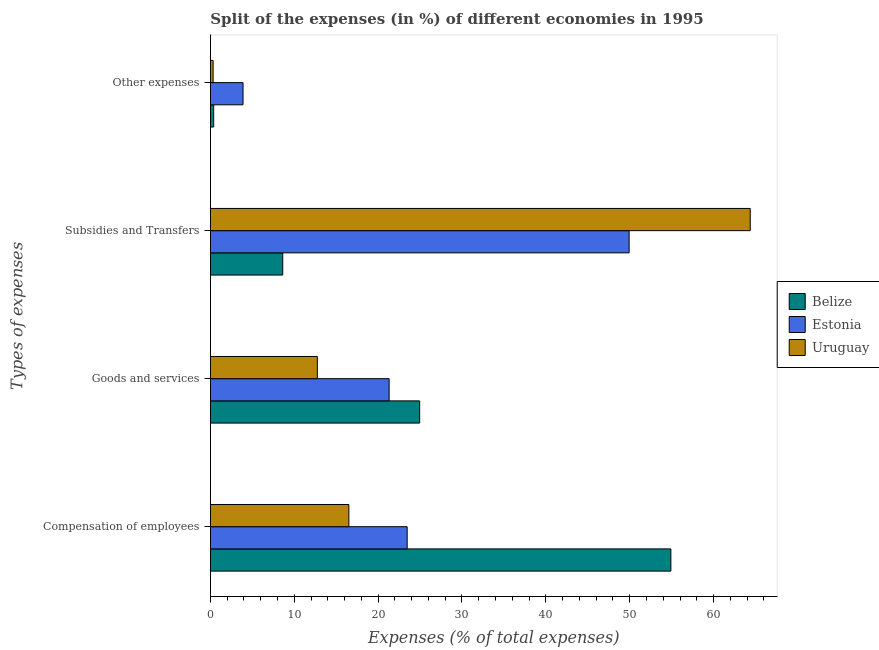How many groups of bars are there?
Your response must be concise. 4. Are the number of bars per tick equal to the number of legend labels?
Offer a very short reply. Yes. How many bars are there on the 4th tick from the top?
Ensure brevity in your answer.  3. How many bars are there on the 3rd tick from the bottom?
Provide a succinct answer. 3. What is the label of the 3rd group of bars from the top?
Give a very brief answer. Goods and services. What is the percentage of amount spent on subsidies in Belize?
Keep it short and to the point. 8.63. Across all countries, what is the maximum percentage of amount spent on goods and services?
Make the answer very short. 24.95. Across all countries, what is the minimum percentage of amount spent on goods and services?
Provide a succinct answer. 12.75. In which country was the percentage of amount spent on goods and services maximum?
Provide a short and direct response. Belize. In which country was the percentage of amount spent on goods and services minimum?
Offer a very short reply. Uruguay. What is the total percentage of amount spent on other expenses in the graph?
Your response must be concise. 4.61. What is the difference between the percentage of amount spent on goods and services in Estonia and that in Uruguay?
Provide a succinct answer. 8.56. What is the difference between the percentage of amount spent on compensation of employees in Estonia and the percentage of amount spent on subsidies in Uruguay?
Ensure brevity in your answer.  -40.9. What is the average percentage of amount spent on subsidies per country?
Your answer should be very brief. 40.97. What is the difference between the percentage of amount spent on other expenses and percentage of amount spent on subsidies in Estonia?
Offer a terse response. -46.04. In how many countries, is the percentage of amount spent on goods and services greater than 60 %?
Your answer should be compact. 0. What is the ratio of the percentage of amount spent on goods and services in Uruguay to that in Belize?
Ensure brevity in your answer.  0.51. Is the percentage of amount spent on goods and services in Belize less than that in Estonia?
Keep it short and to the point. No. Is the difference between the percentage of amount spent on other expenses in Uruguay and Belize greater than the difference between the percentage of amount spent on subsidies in Uruguay and Belize?
Your answer should be very brief. No. What is the difference between the highest and the second highest percentage of amount spent on compensation of employees?
Provide a succinct answer. 31.44. What is the difference between the highest and the lowest percentage of amount spent on other expenses?
Provide a succinct answer. 3.57. In how many countries, is the percentage of amount spent on other expenses greater than the average percentage of amount spent on other expenses taken over all countries?
Provide a succinct answer. 1. Is the sum of the percentage of amount spent on goods and services in Estonia and Belize greater than the maximum percentage of amount spent on other expenses across all countries?
Keep it short and to the point. Yes. What does the 1st bar from the top in Compensation of employees represents?
Make the answer very short. Uruguay. What does the 1st bar from the bottom in Compensation of employees represents?
Ensure brevity in your answer.  Belize. Is it the case that in every country, the sum of the percentage of amount spent on compensation of employees and percentage of amount spent on goods and services is greater than the percentage of amount spent on subsidies?
Make the answer very short. No. Are all the bars in the graph horizontal?
Ensure brevity in your answer.  Yes. How many countries are there in the graph?
Offer a very short reply. 3. Are the values on the major ticks of X-axis written in scientific E-notation?
Make the answer very short. No. Where does the legend appear in the graph?
Your answer should be very brief. Center right. How are the legend labels stacked?
Make the answer very short. Vertical. What is the title of the graph?
Make the answer very short. Split of the expenses (in %) of different economies in 1995. Does "Luxembourg" appear as one of the legend labels in the graph?
Make the answer very short. No. What is the label or title of the X-axis?
Give a very brief answer. Expenses (% of total expenses). What is the label or title of the Y-axis?
Give a very brief answer. Types of expenses. What is the Expenses (% of total expenses) of Belize in Compensation of employees?
Provide a succinct answer. 54.91. What is the Expenses (% of total expenses) in Estonia in Compensation of employees?
Make the answer very short. 23.46. What is the Expenses (% of total expenses) of Uruguay in Compensation of employees?
Make the answer very short. 16.51. What is the Expenses (% of total expenses) of Belize in Goods and services?
Keep it short and to the point. 24.95. What is the Expenses (% of total expenses) in Estonia in Goods and services?
Make the answer very short. 21.31. What is the Expenses (% of total expenses) of Uruguay in Goods and services?
Ensure brevity in your answer.  12.75. What is the Expenses (% of total expenses) in Belize in Subsidies and Transfers?
Ensure brevity in your answer.  8.63. What is the Expenses (% of total expenses) of Estonia in Subsidies and Transfers?
Offer a very short reply. 49.93. What is the Expenses (% of total expenses) in Uruguay in Subsidies and Transfers?
Your answer should be very brief. 64.37. What is the Expenses (% of total expenses) in Belize in Other expenses?
Keep it short and to the point. 0.39. What is the Expenses (% of total expenses) in Estonia in Other expenses?
Make the answer very short. 3.89. What is the Expenses (% of total expenses) of Uruguay in Other expenses?
Your response must be concise. 0.33. Across all Types of expenses, what is the maximum Expenses (% of total expenses) in Belize?
Keep it short and to the point. 54.91. Across all Types of expenses, what is the maximum Expenses (% of total expenses) of Estonia?
Provide a short and direct response. 49.93. Across all Types of expenses, what is the maximum Expenses (% of total expenses) in Uruguay?
Your answer should be very brief. 64.37. Across all Types of expenses, what is the minimum Expenses (% of total expenses) in Belize?
Your answer should be very brief. 0.39. Across all Types of expenses, what is the minimum Expenses (% of total expenses) of Estonia?
Provide a succinct answer. 3.89. Across all Types of expenses, what is the minimum Expenses (% of total expenses) in Uruguay?
Give a very brief answer. 0.33. What is the total Expenses (% of total expenses) of Belize in the graph?
Offer a terse response. 88.88. What is the total Expenses (% of total expenses) of Estonia in the graph?
Your answer should be compact. 98.6. What is the total Expenses (% of total expenses) of Uruguay in the graph?
Provide a short and direct response. 93.96. What is the difference between the Expenses (% of total expenses) in Belize in Compensation of employees and that in Goods and services?
Provide a short and direct response. 29.95. What is the difference between the Expenses (% of total expenses) in Estonia in Compensation of employees and that in Goods and services?
Your answer should be very brief. 2.15. What is the difference between the Expenses (% of total expenses) in Uruguay in Compensation of employees and that in Goods and services?
Give a very brief answer. 3.76. What is the difference between the Expenses (% of total expenses) in Belize in Compensation of employees and that in Subsidies and Transfers?
Keep it short and to the point. 46.28. What is the difference between the Expenses (% of total expenses) of Estonia in Compensation of employees and that in Subsidies and Transfers?
Offer a very short reply. -26.46. What is the difference between the Expenses (% of total expenses) of Uruguay in Compensation of employees and that in Subsidies and Transfers?
Offer a terse response. -47.86. What is the difference between the Expenses (% of total expenses) in Belize in Compensation of employees and that in Other expenses?
Your answer should be compact. 54.51. What is the difference between the Expenses (% of total expenses) in Estonia in Compensation of employees and that in Other expenses?
Provide a succinct answer. 19.57. What is the difference between the Expenses (% of total expenses) of Uruguay in Compensation of employees and that in Other expenses?
Your answer should be very brief. 16.19. What is the difference between the Expenses (% of total expenses) of Belize in Goods and services and that in Subsidies and Transfers?
Provide a succinct answer. 16.33. What is the difference between the Expenses (% of total expenses) in Estonia in Goods and services and that in Subsidies and Transfers?
Offer a very short reply. -28.61. What is the difference between the Expenses (% of total expenses) in Uruguay in Goods and services and that in Subsidies and Transfers?
Your answer should be compact. -51.61. What is the difference between the Expenses (% of total expenses) in Belize in Goods and services and that in Other expenses?
Keep it short and to the point. 24.56. What is the difference between the Expenses (% of total expenses) in Estonia in Goods and services and that in Other expenses?
Provide a succinct answer. 17.42. What is the difference between the Expenses (% of total expenses) in Uruguay in Goods and services and that in Other expenses?
Provide a succinct answer. 12.43. What is the difference between the Expenses (% of total expenses) in Belize in Subsidies and Transfers and that in Other expenses?
Your answer should be very brief. 8.23. What is the difference between the Expenses (% of total expenses) in Estonia in Subsidies and Transfers and that in Other expenses?
Offer a terse response. 46.04. What is the difference between the Expenses (% of total expenses) in Uruguay in Subsidies and Transfers and that in Other expenses?
Your answer should be very brief. 64.04. What is the difference between the Expenses (% of total expenses) of Belize in Compensation of employees and the Expenses (% of total expenses) of Estonia in Goods and services?
Keep it short and to the point. 33.59. What is the difference between the Expenses (% of total expenses) in Belize in Compensation of employees and the Expenses (% of total expenses) in Uruguay in Goods and services?
Your answer should be compact. 42.15. What is the difference between the Expenses (% of total expenses) of Estonia in Compensation of employees and the Expenses (% of total expenses) of Uruguay in Goods and services?
Give a very brief answer. 10.71. What is the difference between the Expenses (% of total expenses) of Belize in Compensation of employees and the Expenses (% of total expenses) of Estonia in Subsidies and Transfers?
Your answer should be compact. 4.98. What is the difference between the Expenses (% of total expenses) in Belize in Compensation of employees and the Expenses (% of total expenses) in Uruguay in Subsidies and Transfers?
Give a very brief answer. -9.46. What is the difference between the Expenses (% of total expenses) of Estonia in Compensation of employees and the Expenses (% of total expenses) of Uruguay in Subsidies and Transfers?
Your answer should be compact. -40.9. What is the difference between the Expenses (% of total expenses) in Belize in Compensation of employees and the Expenses (% of total expenses) in Estonia in Other expenses?
Your response must be concise. 51.01. What is the difference between the Expenses (% of total expenses) of Belize in Compensation of employees and the Expenses (% of total expenses) of Uruguay in Other expenses?
Offer a terse response. 54.58. What is the difference between the Expenses (% of total expenses) in Estonia in Compensation of employees and the Expenses (% of total expenses) in Uruguay in Other expenses?
Offer a terse response. 23.14. What is the difference between the Expenses (% of total expenses) in Belize in Goods and services and the Expenses (% of total expenses) in Estonia in Subsidies and Transfers?
Offer a terse response. -24.97. What is the difference between the Expenses (% of total expenses) of Belize in Goods and services and the Expenses (% of total expenses) of Uruguay in Subsidies and Transfers?
Give a very brief answer. -39.41. What is the difference between the Expenses (% of total expenses) of Estonia in Goods and services and the Expenses (% of total expenses) of Uruguay in Subsidies and Transfers?
Your answer should be compact. -43.05. What is the difference between the Expenses (% of total expenses) in Belize in Goods and services and the Expenses (% of total expenses) in Estonia in Other expenses?
Your answer should be compact. 21.06. What is the difference between the Expenses (% of total expenses) of Belize in Goods and services and the Expenses (% of total expenses) of Uruguay in Other expenses?
Give a very brief answer. 24.63. What is the difference between the Expenses (% of total expenses) in Estonia in Goods and services and the Expenses (% of total expenses) in Uruguay in Other expenses?
Your response must be concise. 20.99. What is the difference between the Expenses (% of total expenses) in Belize in Subsidies and Transfers and the Expenses (% of total expenses) in Estonia in Other expenses?
Your answer should be very brief. 4.73. What is the difference between the Expenses (% of total expenses) in Belize in Subsidies and Transfers and the Expenses (% of total expenses) in Uruguay in Other expenses?
Ensure brevity in your answer.  8.3. What is the difference between the Expenses (% of total expenses) in Estonia in Subsidies and Transfers and the Expenses (% of total expenses) in Uruguay in Other expenses?
Offer a very short reply. 49.6. What is the average Expenses (% of total expenses) in Belize per Types of expenses?
Offer a terse response. 22.22. What is the average Expenses (% of total expenses) of Estonia per Types of expenses?
Your response must be concise. 24.65. What is the average Expenses (% of total expenses) of Uruguay per Types of expenses?
Provide a short and direct response. 23.49. What is the difference between the Expenses (% of total expenses) in Belize and Expenses (% of total expenses) in Estonia in Compensation of employees?
Your response must be concise. 31.44. What is the difference between the Expenses (% of total expenses) of Belize and Expenses (% of total expenses) of Uruguay in Compensation of employees?
Offer a very short reply. 38.4. What is the difference between the Expenses (% of total expenses) of Estonia and Expenses (% of total expenses) of Uruguay in Compensation of employees?
Offer a terse response. 6.95. What is the difference between the Expenses (% of total expenses) in Belize and Expenses (% of total expenses) in Estonia in Goods and services?
Ensure brevity in your answer.  3.64. What is the difference between the Expenses (% of total expenses) of Belize and Expenses (% of total expenses) of Uruguay in Goods and services?
Offer a very short reply. 12.2. What is the difference between the Expenses (% of total expenses) of Estonia and Expenses (% of total expenses) of Uruguay in Goods and services?
Give a very brief answer. 8.56. What is the difference between the Expenses (% of total expenses) of Belize and Expenses (% of total expenses) of Estonia in Subsidies and Transfers?
Keep it short and to the point. -41.3. What is the difference between the Expenses (% of total expenses) of Belize and Expenses (% of total expenses) of Uruguay in Subsidies and Transfers?
Your answer should be compact. -55.74. What is the difference between the Expenses (% of total expenses) of Estonia and Expenses (% of total expenses) of Uruguay in Subsidies and Transfers?
Your answer should be compact. -14.44. What is the difference between the Expenses (% of total expenses) of Belize and Expenses (% of total expenses) of Estonia in Other expenses?
Your answer should be very brief. -3.5. What is the difference between the Expenses (% of total expenses) of Belize and Expenses (% of total expenses) of Uruguay in Other expenses?
Your response must be concise. 0.07. What is the difference between the Expenses (% of total expenses) in Estonia and Expenses (% of total expenses) in Uruguay in Other expenses?
Give a very brief answer. 3.57. What is the ratio of the Expenses (% of total expenses) in Belize in Compensation of employees to that in Goods and services?
Keep it short and to the point. 2.2. What is the ratio of the Expenses (% of total expenses) in Estonia in Compensation of employees to that in Goods and services?
Your answer should be very brief. 1.1. What is the ratio of the Expenses (% of total expenses) in Uruguay in Compensation of employees to that in Goods and services?
Keep it short and to the point. 1.29. What is the ratio of the Expenses (% of total expenses) in Belize in Compensation of employees to that in Subsidies and Transfers?
Provide a succinct answer. 6.37. What is the ratio of the Expenses (% of total expenses) in Estonia in Compensation of employees to that in Subsidies and Transfers?
Give a very brief answer. 0.47. What is the ratio of the Expenses (% of total expenses) in Uruguay in Compensation of employees to that in Subsidies and Transfers?
Ensure brevity in your answer.  0.26. What is the ratio of the Expenses (% of total expenses) in Belize in Compensation of employees to that in Other expenses?
Your response must be concise. 139.55. What is the ratio of the Expenses (% of total expenses) of Estonia in Compensation of employees to that in Other expenses?
Provide a short and direct response. 6.03. What is the ratio of the Expenses (% of total expenses) in Uruguay in Compensation of employees to that in Other expenses?
Provide a short and direct response. 50.77. What is the ratio of the Expenses (% of total expenses) in Belize in Goods and services to that in Subsidies and Transfers?
Keep it short and to the point. 2.89. What is the ratio of the Expenses (% of total expenses) in Estonia in Goods and services to that in Subsidies and Transfers?
Offer a very short reply. 0.43. What is the ratio of the Expenses (% of total expenses) in Uruguay in Goods and services to that in Subsidies and Transfers?
Your response must be concise. 0.2. What is the ratio of the Expenses (% of total expenses) in Belize in Goods and services to that in Other expenses?
Keep it short and to the point. 63.42. What is the ratio of the Expenses (% of total expenses) of Estonia in Goods and services to that in Other expenses?
Keep it short and to the point. 5.48. What is the ratio of the Expenses (% of total expenses) in Uruguay in Goods and services to that in Other expenses?
Your answer should be compact. 39.21. What is the ratio of the Expenses (% of total expenses) in Belize in Subsidies and Transfers to that in Other expenses?
Make the answer very short. 21.92. What is the ratio of the Expenses (% of total expenses) in Estonia in Subsidies and Transfers to that in Other expenses?
Give a very brief answer. 12.83. What is the ratio of the Expenses (% of total expenses) in Uruguay in Subsidies and Transfers to that in Other expenses?
Your answer should be compact. 197.92. What is the difference between the highest and the second highest Expenses (% of total expenses) in Belize?
Provide a short and direct response. 29.95. What is the difference between the highest and the second highest Expenses (% of total expenses) of Estonia?
Your answer should be very brief. 26.46. What is the difference between the highest and the second highest Expenses (% of total expenses) of Uruguay?
Offer a very short reply. 47.86. What is the difference between the highest and the lowest Expenses (% of total expenses) in Belize?
Keep it short and to the point. 54.51. What is the difference between the highest and the lowest Expenses (% of total expenses) of Estonia?
Give a very brief answer. 46.04. What is the difference between the highest and the lowest Expenses (% of total expenses) in Uruguay?
Offer a very short reply. 64.04. 